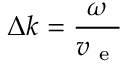<formula> <loc_0><loc_0><loc_500><loc_500>\Delta k = \frac { \omega } { v _ { e } }</formula> 